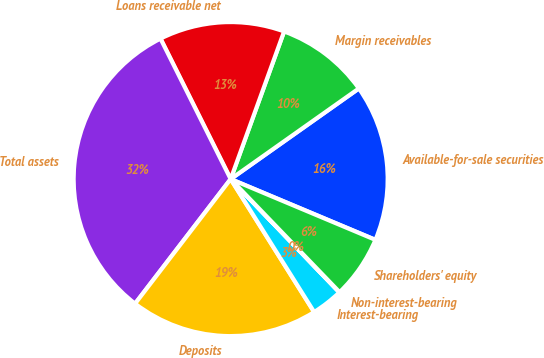<chart> <loc_0><loc_0><loc_500><loc_500><pie_chart><fcel>Available-for-sale securities<fcel>Margin receivables<fcel>Loans receivable net<fcel>Total assets<fcel>Deposits<fcel>Interest-bearing<fcel>Non-interest-bearing<fcel>Shareholders' equity<nl><fcel>16.12%<fcel>9.68%<fcel>12.9%<fcel>32.21%<fcel>19.34%<fcel>3.25%<fcel>0.03%<fcel>6.47%<nl></chart> 